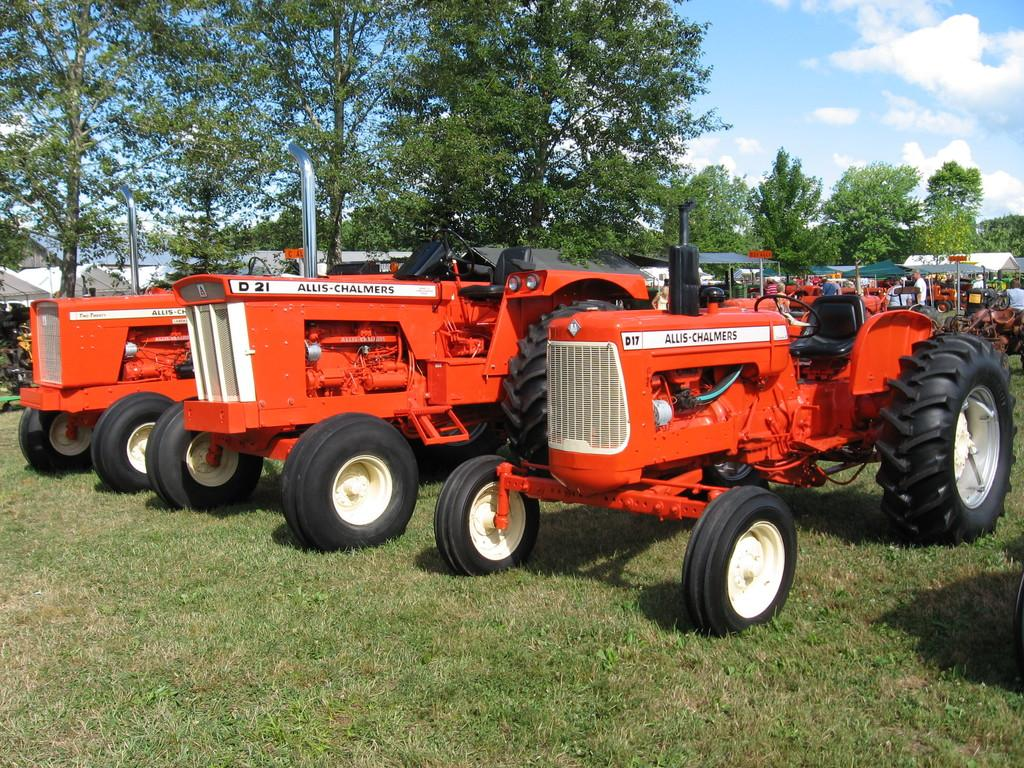What types of objects can be seen in the image? There are vehicles and sheds in the image. Are there any living beings present in the image? Yes, there are people in the image. What is the ground like in the image? The ground with grass is visible in the image. What type of vegetation can be seen in the image? There are trees in the image. What is visible in the background of the image? The sky is visible in the image, and clouds are present in the sky. What type of muscle can be seen flexing in the image? There is no muscle present in the image. How many pizzas are being served in the image? There are no pizzas present in the image. 